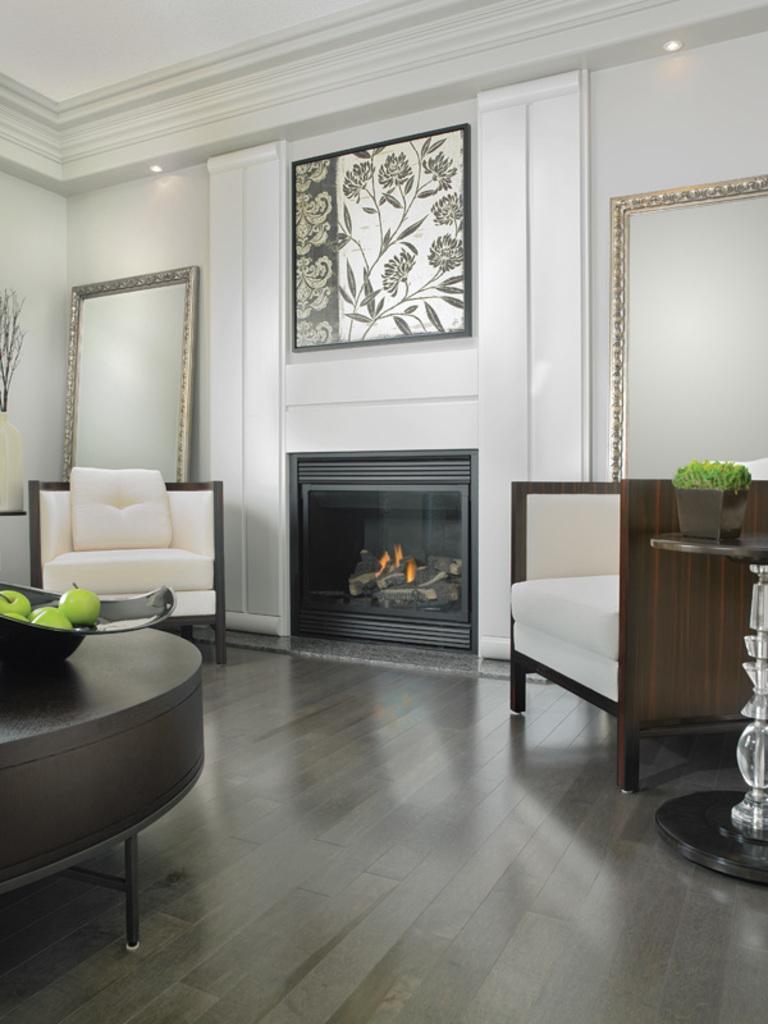In one or two sentences, can you explain what this image depicts? In this image i can see 2 couches a table with some fruits on it, and in the background i can see a mirror, a wall and a fire place. 